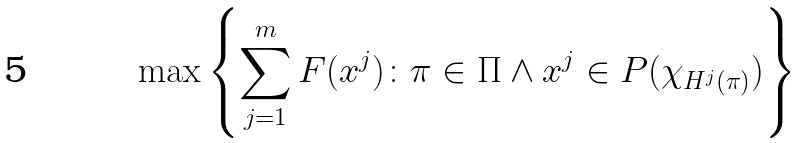<formula> <loc_0><loc_0><loc_500><loc_500>\max \left \{ \sum _ { j = 1 } ^ { m } F ( x ^ { j } ) \colon \pi \in \Pi \land x ^ { j } \in P ( \chi _ { H ^ { j } ( \pi ) } ) \right \}</formula> 